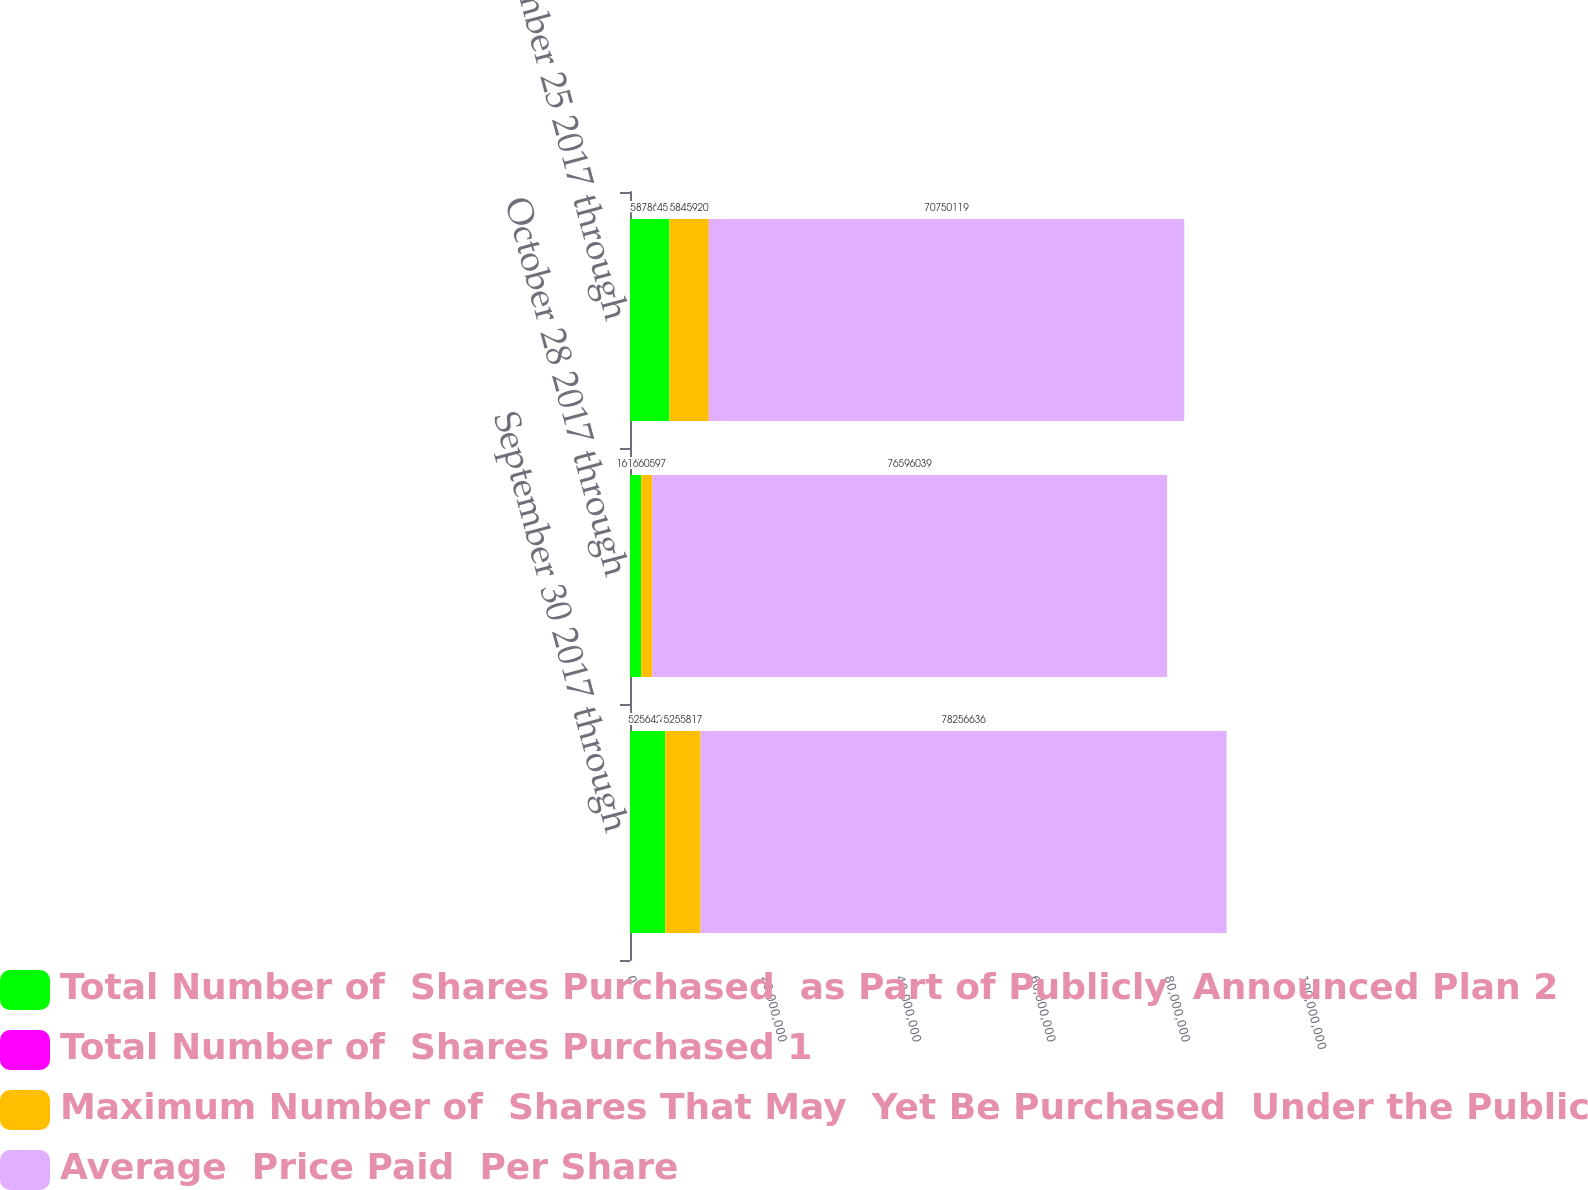<chart> <loc_0><loc_0><loc_500><loc_500><stacked_bar_chart><ecel><fcel>September 30 2017 through<fcel>October 28 2017 through<fcel>November 25 2017 through<nl><fcel>Total Number of  Shares Purchased  as Part of Publicly  Announced Plan 2<fcel>5.25643e+06<fcel>1.66094e+06<fcel>5.87868e+06<nl><fcel>Total Number of  Shares Purchased 1<fcel>46<fcel>45.84<fcel>45.84<nl><fcel>Maximum Number of  Shares That May  Yet Be Purchased  Under the Publicly  Announced Plan<fcel>5.25582e+06<fcel>1.6606e+06<fcel>5.84592e+06<nl><fcel>Average  Price Paid  Per Share<fcel>7.82566e+07<fcel>7.6596e+07<fcel>7.07501e+07<nl></chart> 